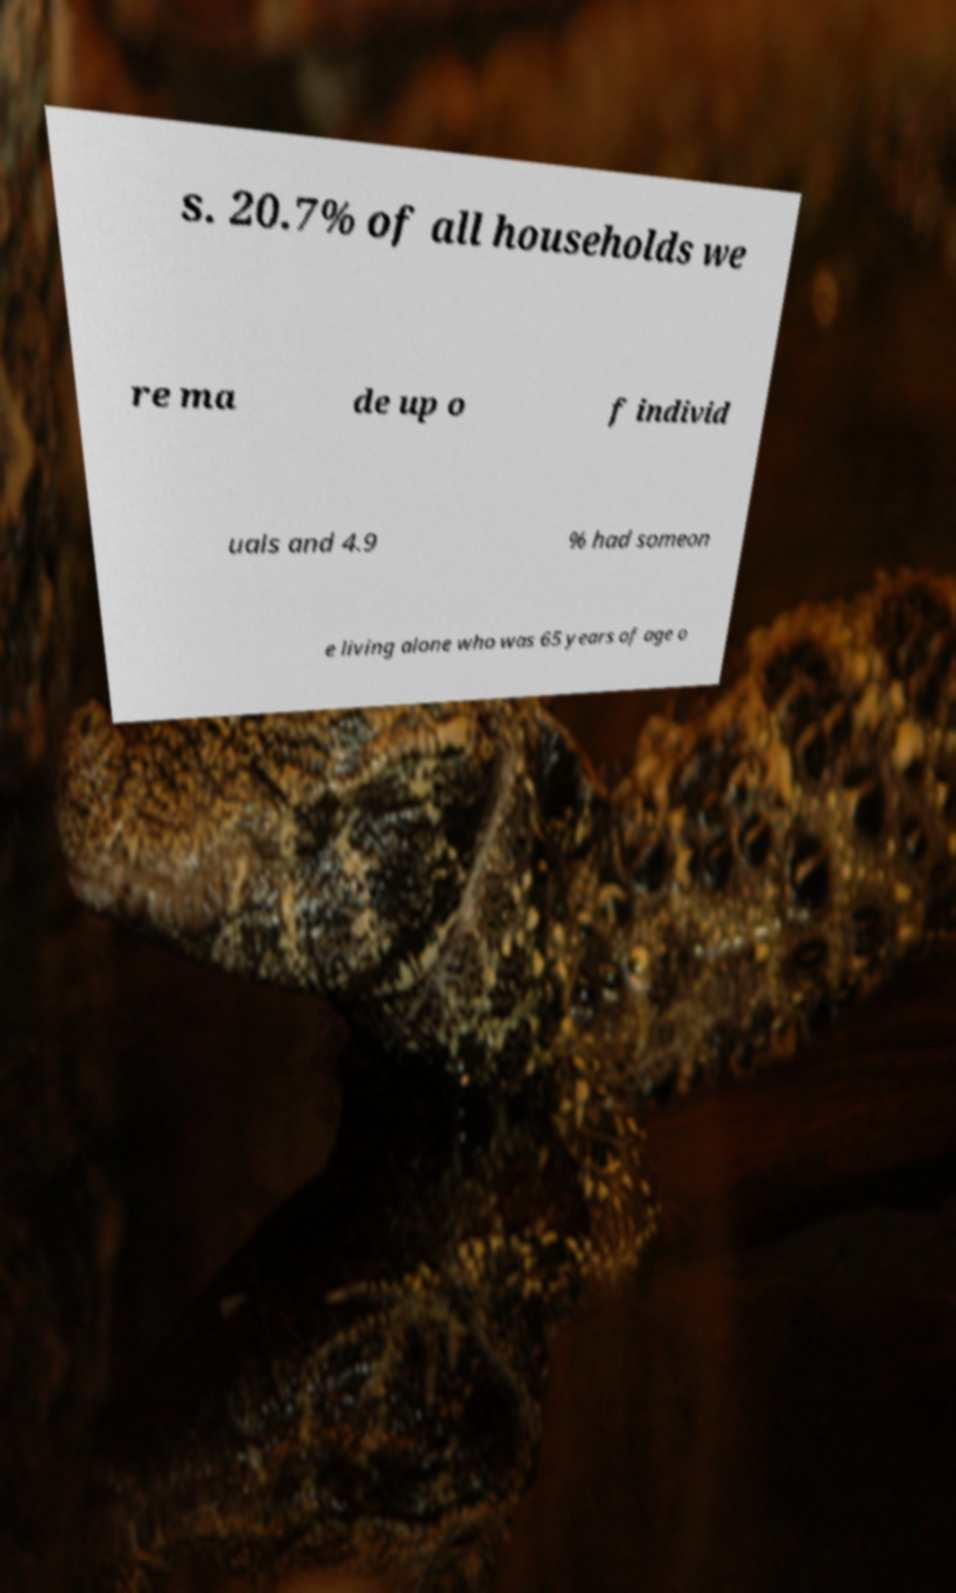For documentation purposes, I need the text within this image transcribed. Could you provide that? s. 20.7% of all households we re ma de up o f individ uals and 4.9 % had someon e living alone who was 65 years of age o 